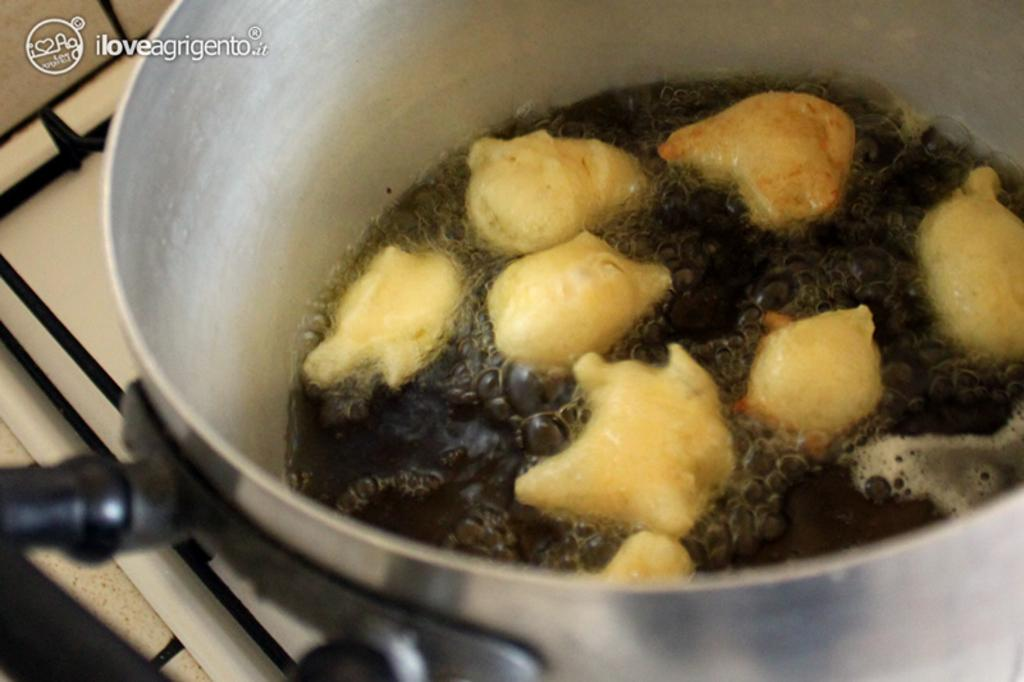What is being cooked on the stove in the image? There are food items in a vessel on the stove in the image. Can you describe any text that is visible in the image? There is some text at the top of the image. What type of yak can be seen conducting a science experiment in the image? There is no yak or science experiment present in the image. 